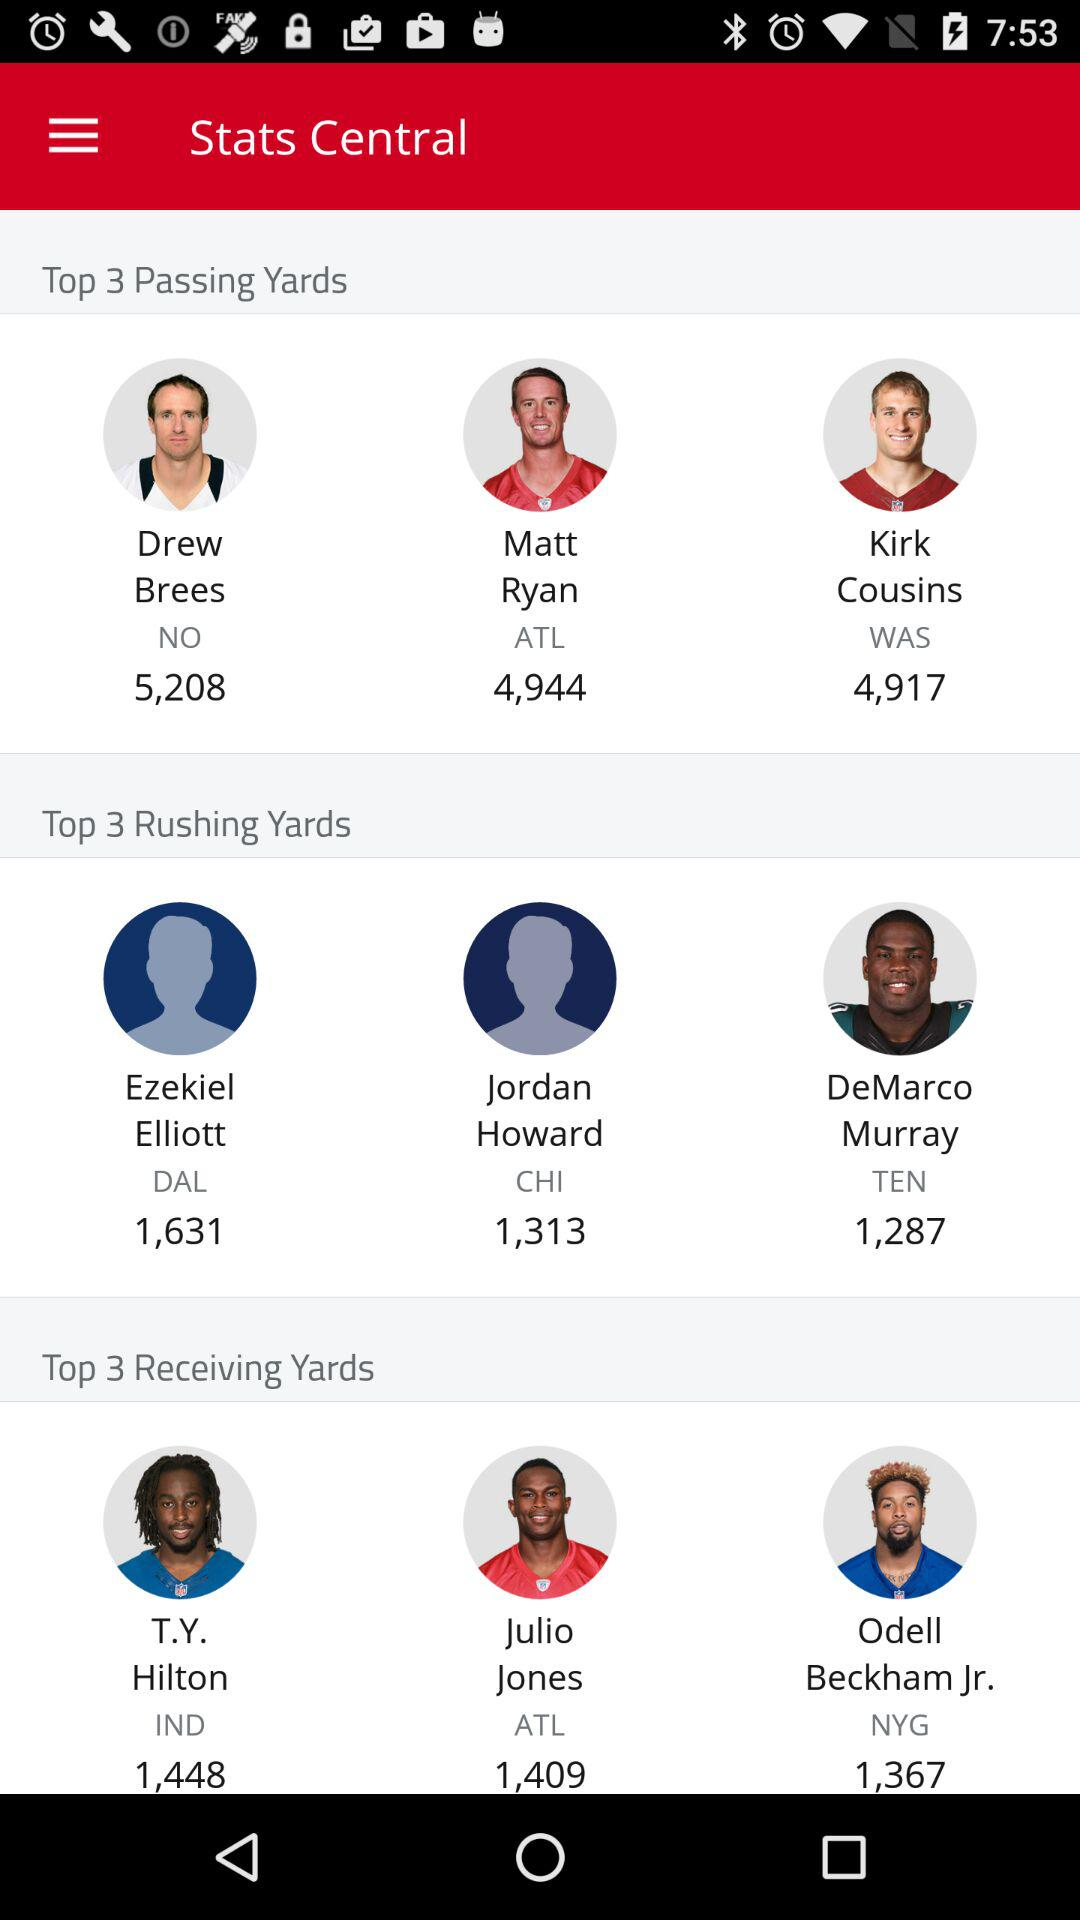How many more receiving yards does T.Y. Hilton have than Julio Jones?
Answer the question using a single word or phrase. 39 